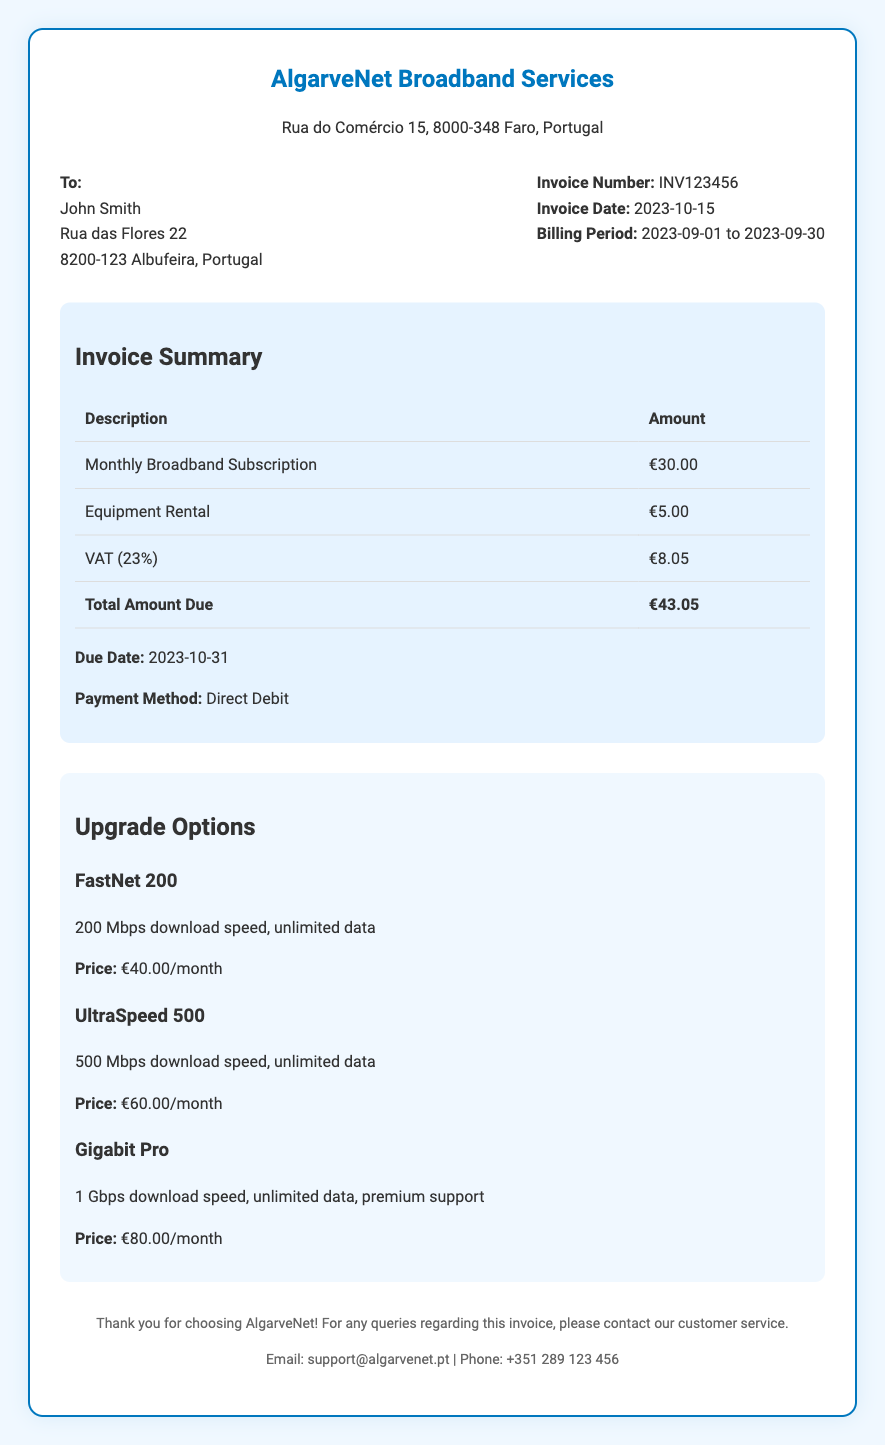What is the invoice number? The invoice number is specifically stated in the document for reference and is an identifying code for this particular invoice.
Answer: INV123456 What is the total amount due? The total amount due is clearly stated at the bottom of the invoice details section, representing the total cost to be paid.
Answer: €43.05 What is the due date for this invoice? The due date for the invoice is mentioned directly and indicates when the payment is required by the service provider.
Answer: 2023-10-31 What is included in the monthly broadband subscription? The invoice lists the components of the charges, which categorizes the charges, including the main subscription fee.
Answer: Monthly Broadband Subscription How much is the VAT charged? The VAT amount is provided in the invoice, specifically calculated as part of the total charges for the month.
Answer: €8.05 What are the speeds for the FastNet 200 upgrade? The speed for the FastNet 200 upgrade is mentioned as part of the upgrade options, highlighting the service features offered.
Answer: 200 Mbps What is the price for the Gigabit Pro upgrade? The price for the Gigabit Pro upgrade is provided among the upgrade options, indicating its cost to the customer.
Answer: €80.00/month Which payment method is used for this invoice? The payment method is explicitly stated on the invoice, indicating how the payment will be processed.
Answer: Direct Debit How long is the billing period? The billing period is specified in the document and indicates the timeframe for the services covered by this invoice.
Answer: 2023-09-01 to 2023-09-30 